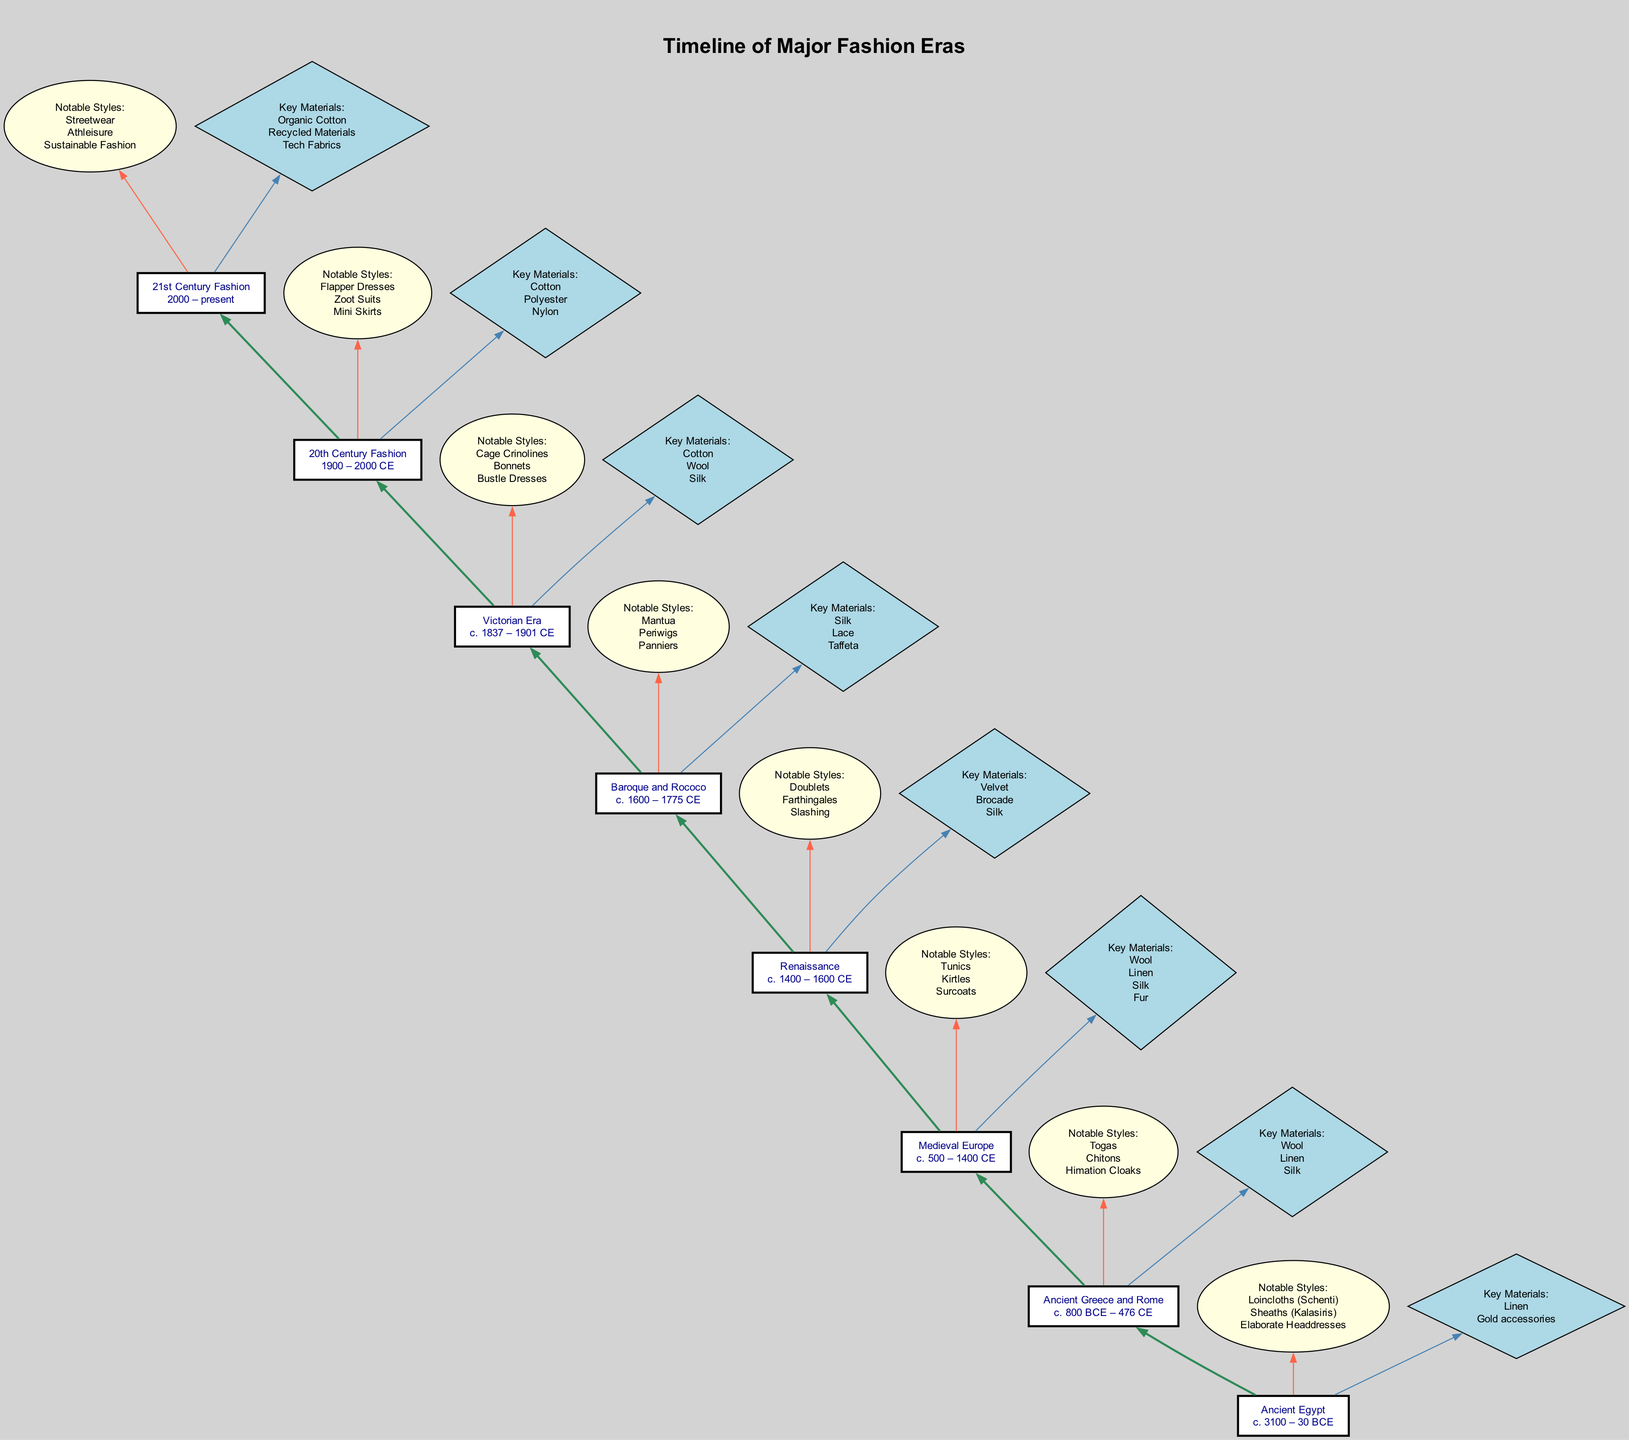What is the time period for the Victorian Era? The Victorian Era is represented in the diagram with the time period "c. 1837 – 1901 CE" noted in the corresponding node for that era.
Answer: c. 1837 – 1901 CE How many notable styles are listed for the Renaissance? The diagram indicates that the Renaissance has three notable styles listed in the corresponding node: "Doublets", "Farthingales", "Slashing".
Answer: 3 Which era features "Mantua" as a notable style? By analyzing the diagram, it is evident that "Mantua" is listed under the notable styles for the Baroque and Rococo era, which is the corresponding step in the flow.
Answer: Baroque and Rococo What key materials are associated with Ancient Egypt? In the diagram for Ancient Egypt, the key materials listed are "Linen" and "Gold accessories", which are clearly stated in the designated node for that era.
Answer: Linen, Gold accessories Which two eras are connected directly by an edge in the diagram? The diagram shows that each era is connected through edges leading upward, specifically, the edge from "20th Century Fashion" to "21st Century Fashion" indicates a direct connection.
Answer: 20th Century Fashion, 21st Century Fashion What notable style appears in both the Victorian Era and 20th Century Fashion? By comparing the styles across both eras in the diagram, it is found that styles such as "Dresses" can be associated, though none directly overlap. Therefore, uniqueness is observed.
Answer: None How does the fashion evolution progress from "Ancient Greece and Rome" to "Medieval Europe"? The diagram illustrates a flow moving from the node for "Ancient Greece and Rome" upwards to "Medieval Europe", indicating that Medieval Europe is the successive era following Ancient Greece and Rome.
Answer: Medieval Europe What is the last fashion era depicted in this timeline? According to the diagram, the last node at the top represents "21st Century Fashion" which indicates it is the most current era being described in this timeline.
Answer: 21st Century Fashion Which key material is common in both the Renaissance and Baroque and Rococo eras? By examining the corresponding key materials listed in both the Renaissance and Baroque and Rococo nodes, "Silk" is identified as a common material between the two timelines.
Answer: Silk 